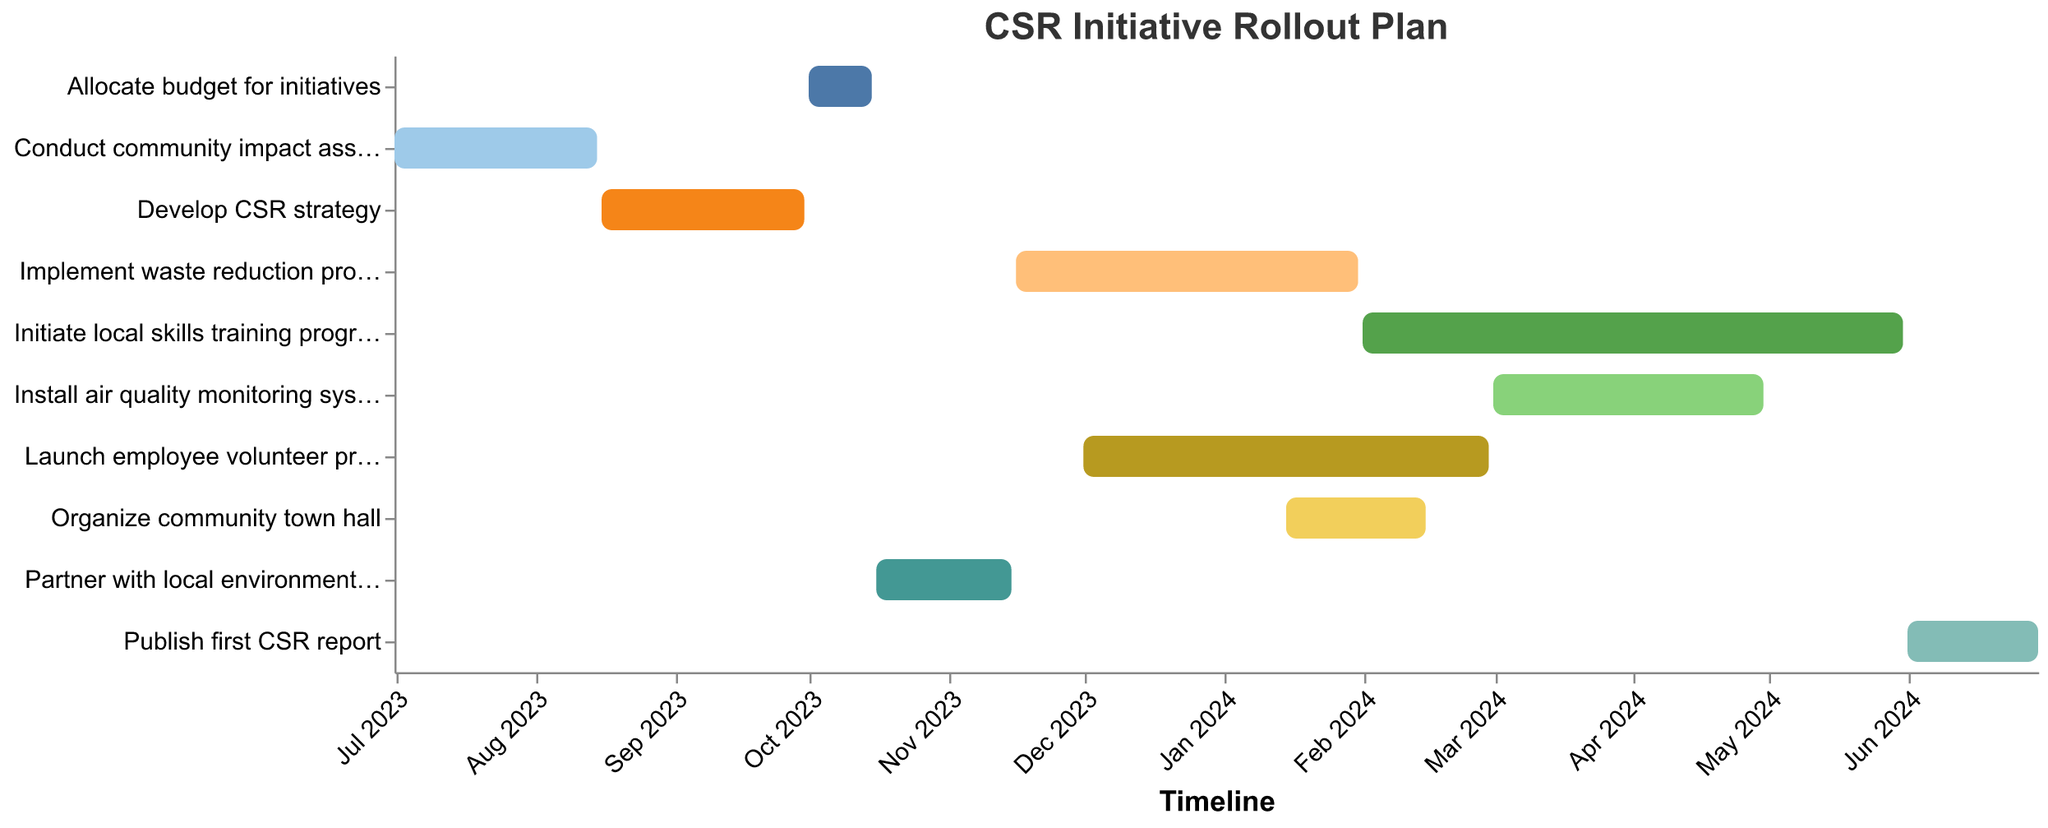What is the title of the figure? The title is usually located at the top of the chart. It reads "CSR Initiative Rollout Plan".
Answer: CSR Initiative Rollout Plan When does the "Develop CSR strategy" task begin and end? Identify the task "Develop CSR strategy". From the chart, it starts on August 16, 2023, and ends on September 30, 2023.
Answer: August 16, 2023, to September 30, 2023 Which task has the longest duration? By comparing the duration of all tasks, "Initiate local skills training program" has a duration of 121 days, which is the longest.
Answer: Initiate local skills training program During which months will the "Launch employee volunteer program" take place? The "Launch employee volunteer program" starts on December 1, 2023, and ends on February 29, 2024. This period spans December, January, and February.
Answer: December, January, February How many days is the "Implement waste reduction program" running for? The duration for "Implement waste reduction program" is given directly as 77 days.
Answer: 77 days Which task starts the earliest? The task that starts the earliest is "Conduct community impact assessment," starting on July 1, 2023.
Answer: Conduct community impact assessment Which two tasks overlap in January 2024? By looking at the timeline, "Implement waste reduction program" (until January 31) and "Organize community town hall" (starts January 15) overlap in January 2024.
Answer: Implement waste reduction program and Organize community town hall How many tasks are planned to be conducted in 2023? Check the start and end dates of all tasks. Those that have dates within 2023 are: "Conduct community impact assessment," "Develop CSR strategy," "Allocate budget for initiatives," "Partner with local environmental NGO," "Implement waste reduction program," and "Launch employee volunteer program." There are 6 such tasks.
Answer: 6 tasks What is the color scheme used for indicating tasks? The chart uses different colors from the "tableau20" color scheme to differentiate between tasks.
Answer: tableau20 Which task has the shortest duration, and how long is it? The task "Allocate budget for initiatives" has the shortest duration of 15 days.
Answer: Allocate budget for initiatives, 15 days 